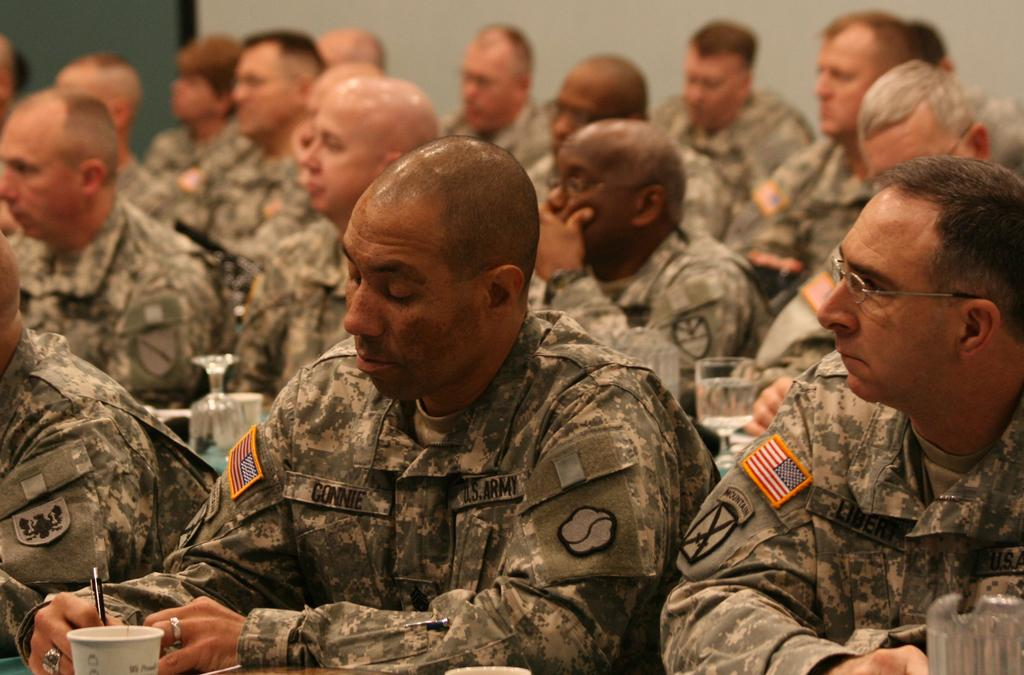What type of people can be seen in the image? There are soldiers in the image. Can you describe any objects in the image? There is a glass at the front of the image. What type of spring is visible in the image? There is no spring present in the image. What kind of party is happening in the image? There is no party depicted in the image. 